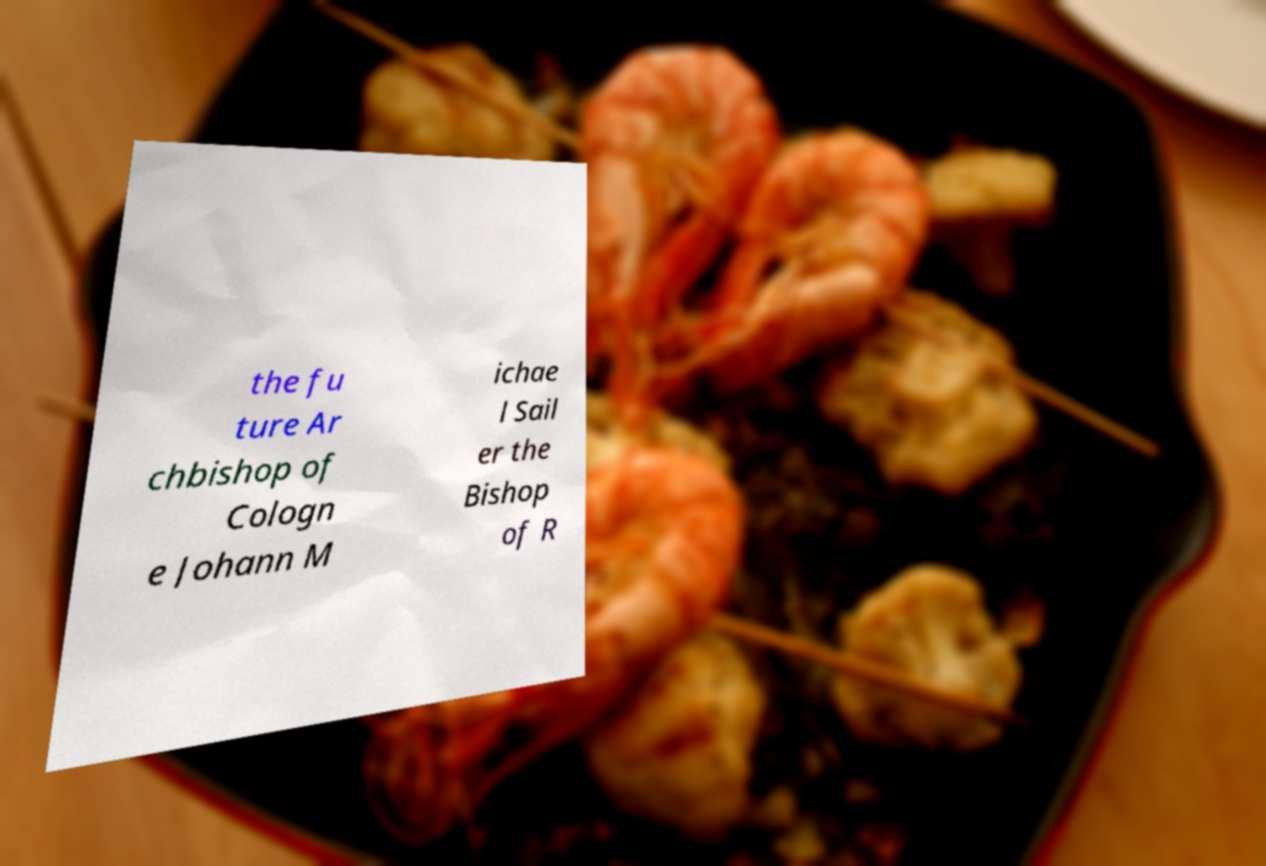Please identify and transcribe the text found in this image. the fu ture Ar chbishop of Cologn e Johann M ichae l Sail er the Bishop of R 